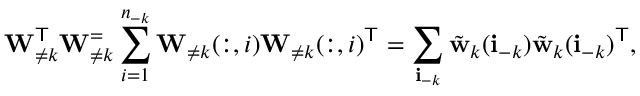Convert formula to latex. <formula><loc_0><loc_0><loc_500><loc_500>W _ { \neq k } ^ { T } W _ { \neq k } ^ { = } \sum _ { i = 1 } ^ { n _ { - k } } W _ { \neq k } ( \colon , i ) W _ { \neq k } ( \colon , i ) ^ { T } = \sum _ { i _ { - k } } \tilde { w } _ { k } ( i _ { - k } ) \tilde { w } _ { k } ( i _ { - k } ) ^ { T } ,</formula> 